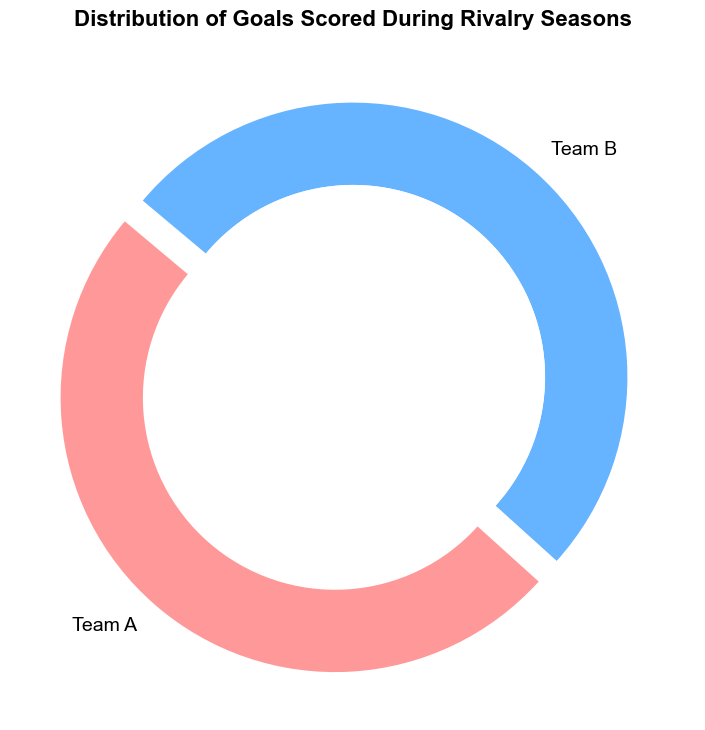What's the total number of goals scored by Team A? To find the total number of goals scored by Team A, look at the ring chart and sum up all the goals scored by Team A over the full span of matchups.
Answer: 47 What's the total number of goals scored by Team B? To find the total number of goals scored by Team B, look at the ring chart and sum up all the goals scored by Team B over the full span of matchups.
Answer: 40 Which team scored a higher percentage of the total goals? The ring chart shows the percentage of total goals scored by each team. Compare the percentages displayed for Team A and Team B. Team A has a higher percentage.
Answer: Team A What's the goal difference between Team A and Team B? First, find the total goals scored by each team. Team A scored 47 goals, and Team B scored 40 goals. The goal difference is calculated by subtracting the goals of Team B from Team A's goals, which is 47 - 40.
Answer: 7 During which match was the highest number of goals scored in total? Identify the match with the highest combined score by summing up the goals scored by both teams for each match. The highest total is in Match 16 where the score was 3-4, equaling 7 goals.
Answer: Match 16 What is the average number of goals scored by Team A per match? First, find the total number of goals scored by Team A, which is 47. There are 20 matches, so the average is calculated as 47 goals divided by 20 matches.
Answer: 2.35 Are there any matches where both teams scored the same number of goals? Look at the breakdown by match and find matches where both teams scored an equal number of goals. These occur in Match 4 (2 - 2), Match 6 (3 - 3), Match 11 (2 - 2), and Match 20 (3 - 3).
Answer: Yes Which match had the largest margin of victory, and which team won? Check the goal differences in each match and identify the one with the largest difference. It is Match 8 with a score of 2-4, and Team B won by 2 goals.
Answer: Match 8, Team B How many matches had a total of 5 or more goals scored? Sum up the goals from both teams for each match and count the number of matches where the combined total is 5 or more goals. These are Match 2, Match 8, Match 13, Match 16, Match 18, and Match 19. There are 6 such matches.
Answer: 6 